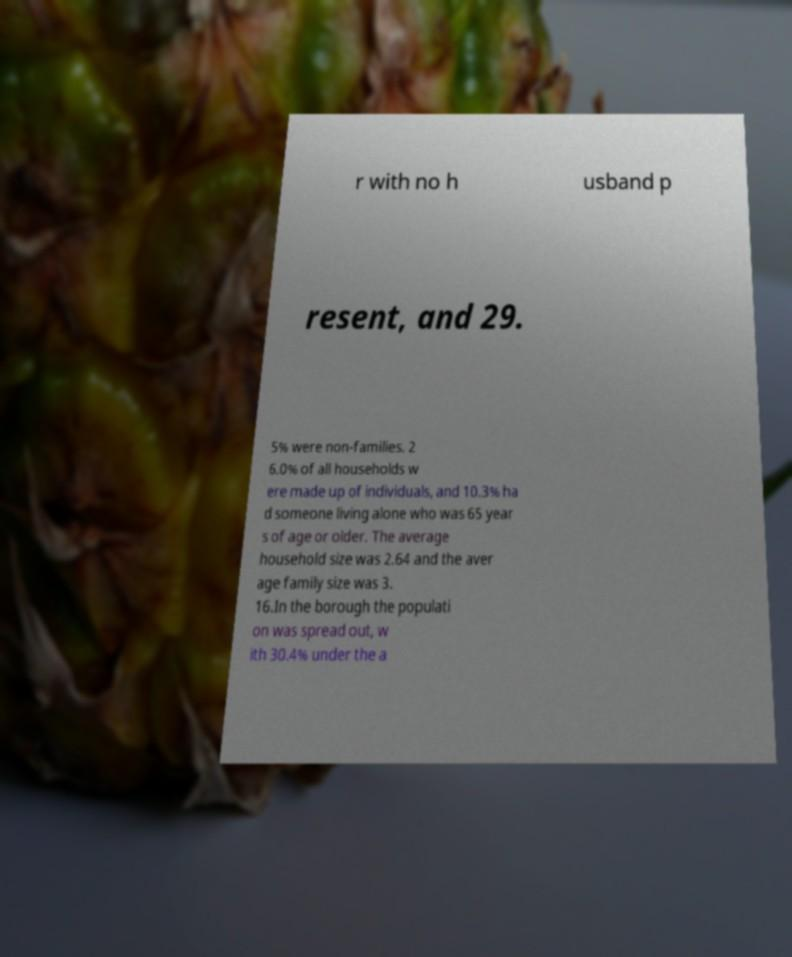What messages or text are displayed in this image? I need them in a readable, typed format. r with no h usband p resent, and 29. 5% were non-families. 2 6.0% of all households w ere made up of individuals, and 10.3% ha d someone living alone who was 65 year s of age or older. The average household size was 2.64 and the aver age family size was 3. 16.In the borough the populati on was spread out, w ith 30.4% under the a 